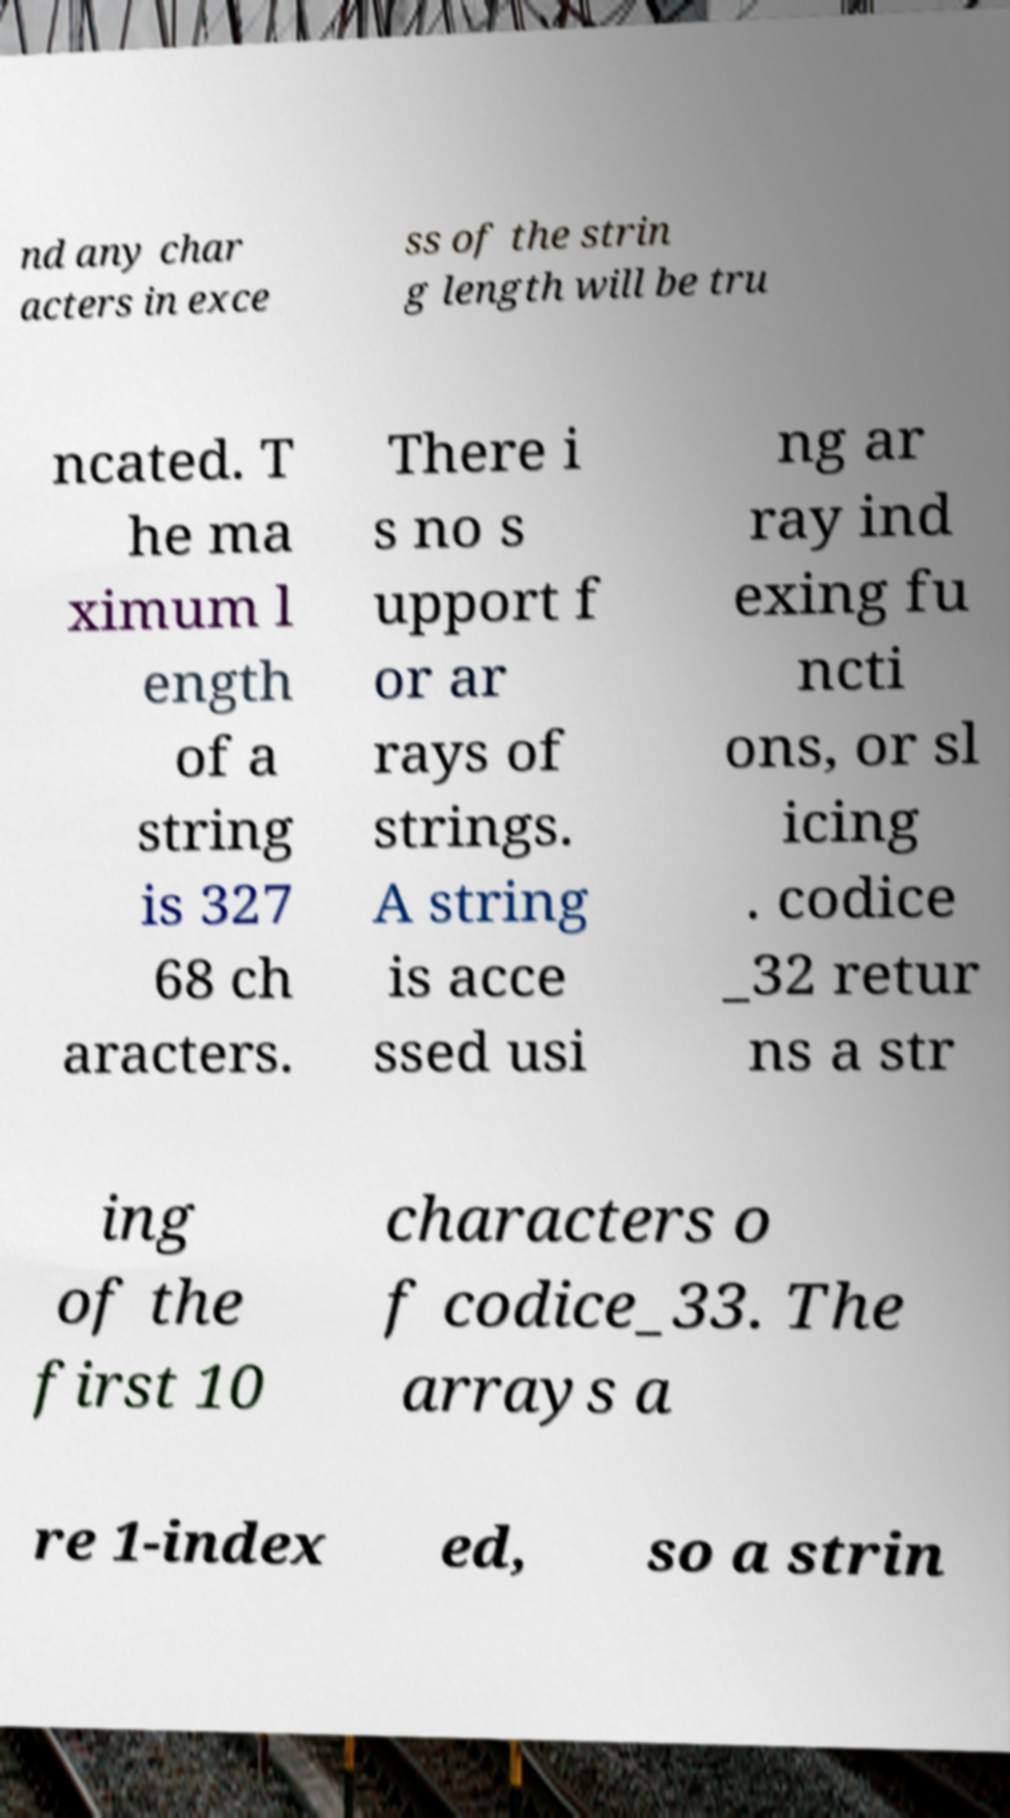What messages or text are displayed in this image? I need them in a readable, typed format. nd any char acters in exce ss of the strin g length will be tru ncated. T he ma ximum l ength of a string is 327 68 ch aracters. There i s no s upport f or ar rays of strings. A string is acce ssed usi ng ar ray ind exing fu ncti ons, or sl icing . codice _32 retur ns a str ing of the first 10 characters o f codice_33. The arrays a re 1-index ed, so a strin 